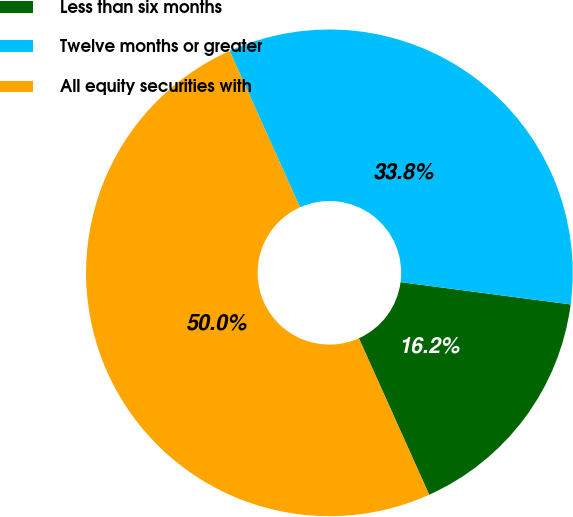Convert chart to OTSL. <chart><loc_0><loc_0><loc_500><loc_500><pie_chart><fcel>Less than six months<fcel>Twelve months or greater<fcel>All equity securities with<nl><fcel>16.2%<fcel>33.8%<fcel>50.0%<nl></chart> 